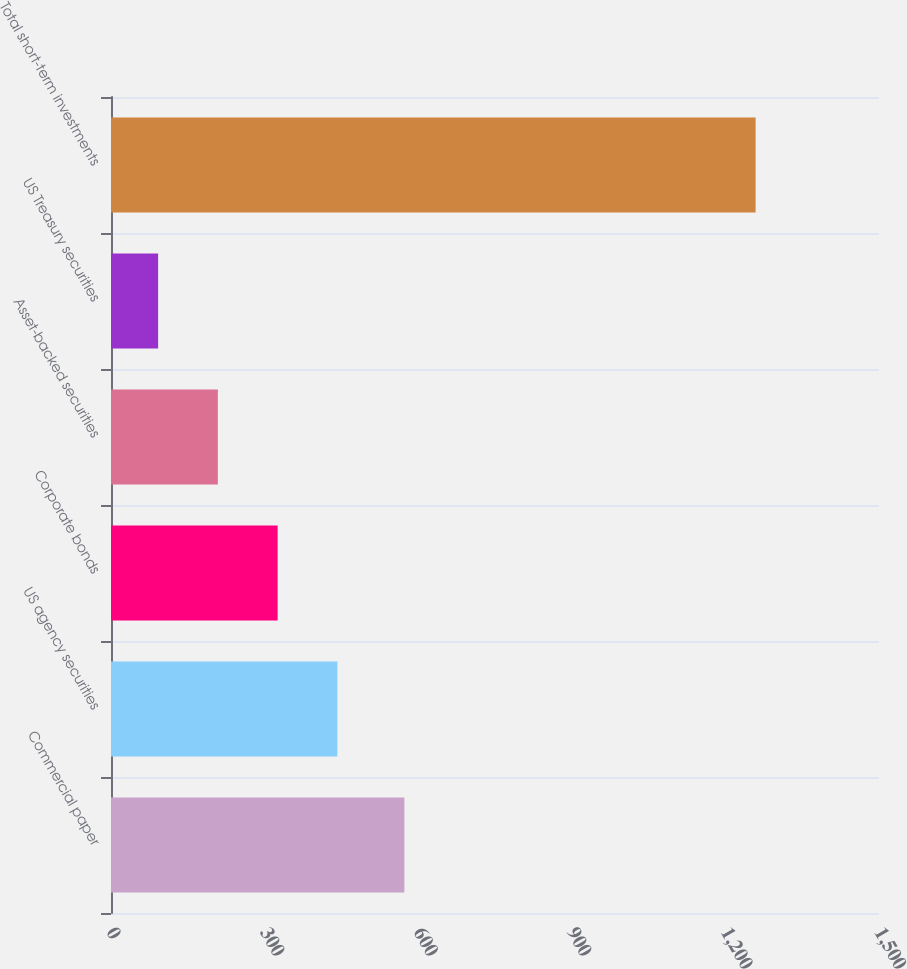Convert chart to OTSL. <chart><loc_0><loc_0><loc_500><loc_500><bar_chart><fcel>Commercial paper<fcel>US agency securities<fcel>Corporate bonds<fcel>Asset-backed securities<fcel>US Treasury securities<fcel>Total short-term investments<nl><fcel>573<fcel>442.1<fcel>325.4<fcel>208.7<fcel>92<fcel>1259<nl></chart> 